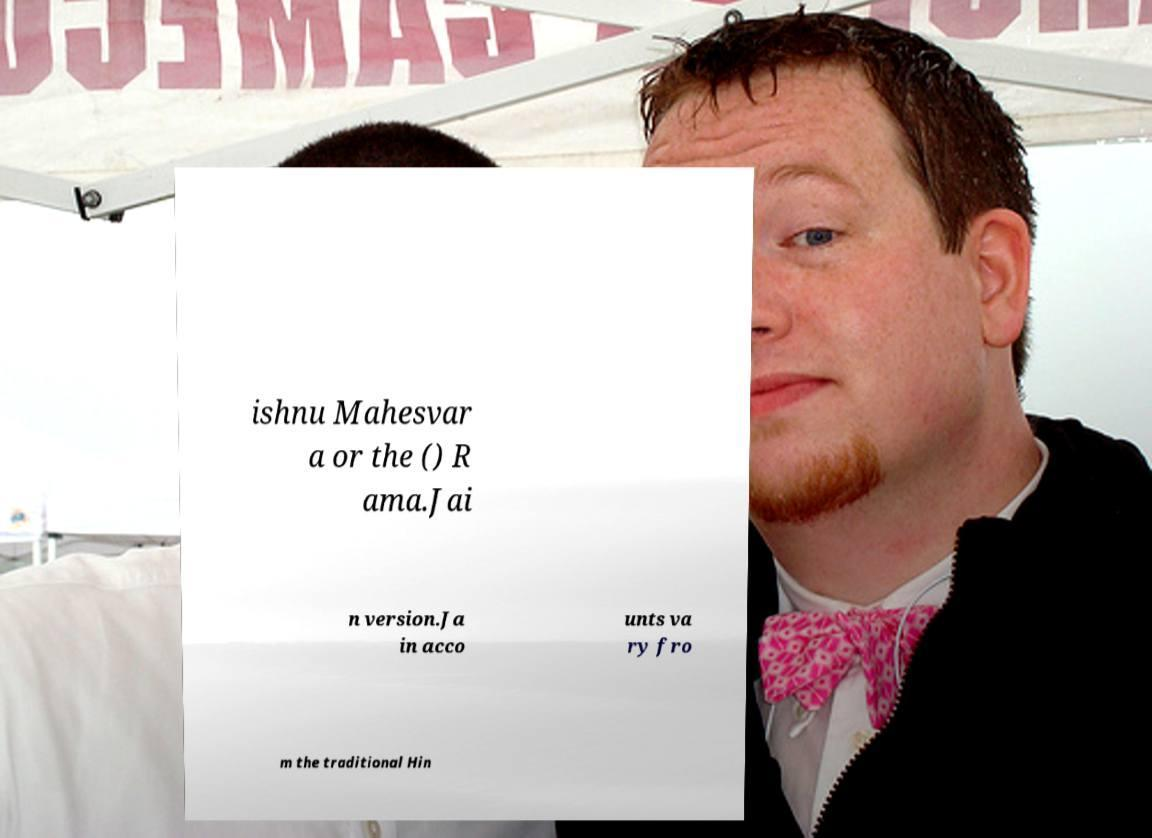For documentation purposes, I need the text within this image transcribed. Could you provide that? ishnu Mahesvar a or the () R ama.Jai n version.Ja in acco unts va ry fro m the traditional Hin 